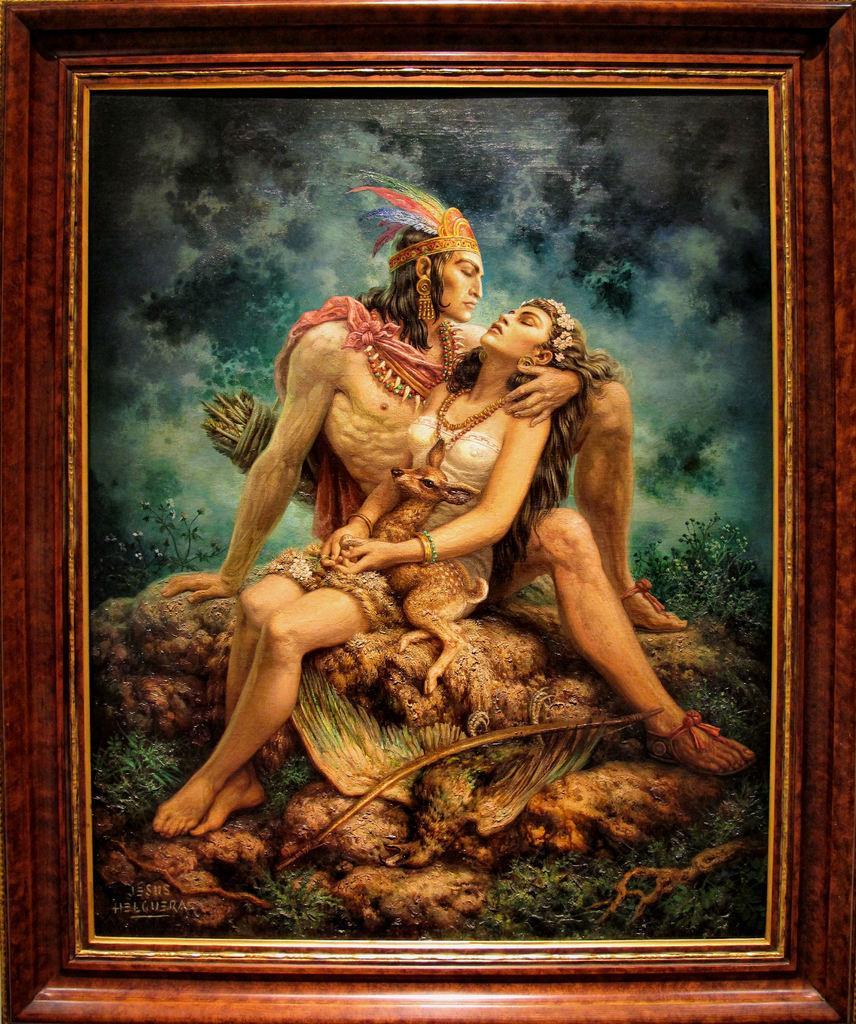How would you summarize this image in a sentence or two? In this picture we can see a photo with frame and in the photo there are two persons and a deer. On the photo, it is written something. 